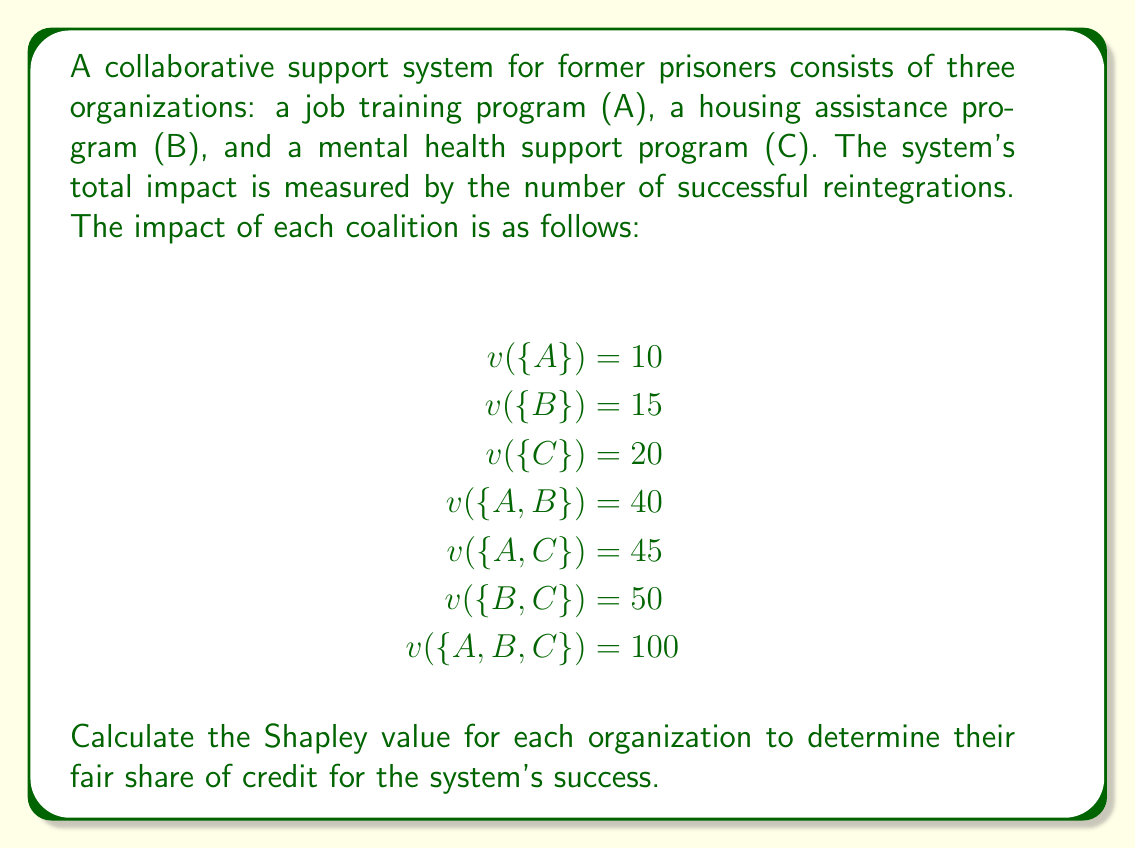Can you answer this question? To calculate the Shapley value for each organization, we need to determine their marginal contributions in all possible coalition formations. The Shapley value formula is:

$$\phi_i(v) = \sum_{S \subseteq N \setminus \{i\}} \frac{|S|!(n-|S|-1)!}{n!}[v(S \cup \{i\}) - v(S)]$$

Where:
$n$ is the total number of players (organizations)
$S$ is a subset of players not including player $i$
$v(S)$ is the value of coalition $S$

For each organization:

1. Job training program (A):
   $\phi_A = \frac{2!(3-2-1)!}{3!}[100-50] + \frac{1!(3-1-1)!}{3!}[45-20] + \frac{1!(3-1-1)!}{3!}[40-15] + \frac{0!(3-0-1)!}{3!}[10-0]$
   $= \frac{1}{3}(50) + \frac{1}{6}(25) + \frac{1}{6}(25) + \frac{1}{3}(10)$
   $= 16.67 + 4.17 + 4.17 + 3.33 = 28.34$

2. Housing assistance program (B):
   $\phi_B = \frac{2!(3-2-1)!}{3!}[100-45] + \frac{1!(3-1-1)!}{3!}[50-20] + \frac{1!(3-1-1)!}{3!}[40-10] + \frac{0!(3-0-1)!}{3!}[15-0]$
   $= \frac{1}{3}(55) + \frac{1}{6}(30) + \frac{1}{6}(30) + \frac{1}{3}(15)$
   $= 18.33 + 5 + 5 + 5 = 33.33$

3. Mental health support program (C):
   $\phi_C = \frac{2!(3-2-1)!}{3!}[100-40] + \frac{1!(3-1-1)!}{3!}[50-15] + \frac{1!(3-1-1)!}{3!}[45-10] + \frac{0!(3-0-1)!}{3!}[20-0]$
   $= \frac{1}{3}(60) + \frac{1}{6}(35) + \frac{1}{6}(35) + \frac{1}{3}(20)$
   $= 20 + 5.83 + 5.83 + 6.67 = 38.33$
Answer: The Shapley values for each organization are:
Job training program (A): 28.34
Housing assistance program (B): 33.33
Mental health support program (C): 38.33 